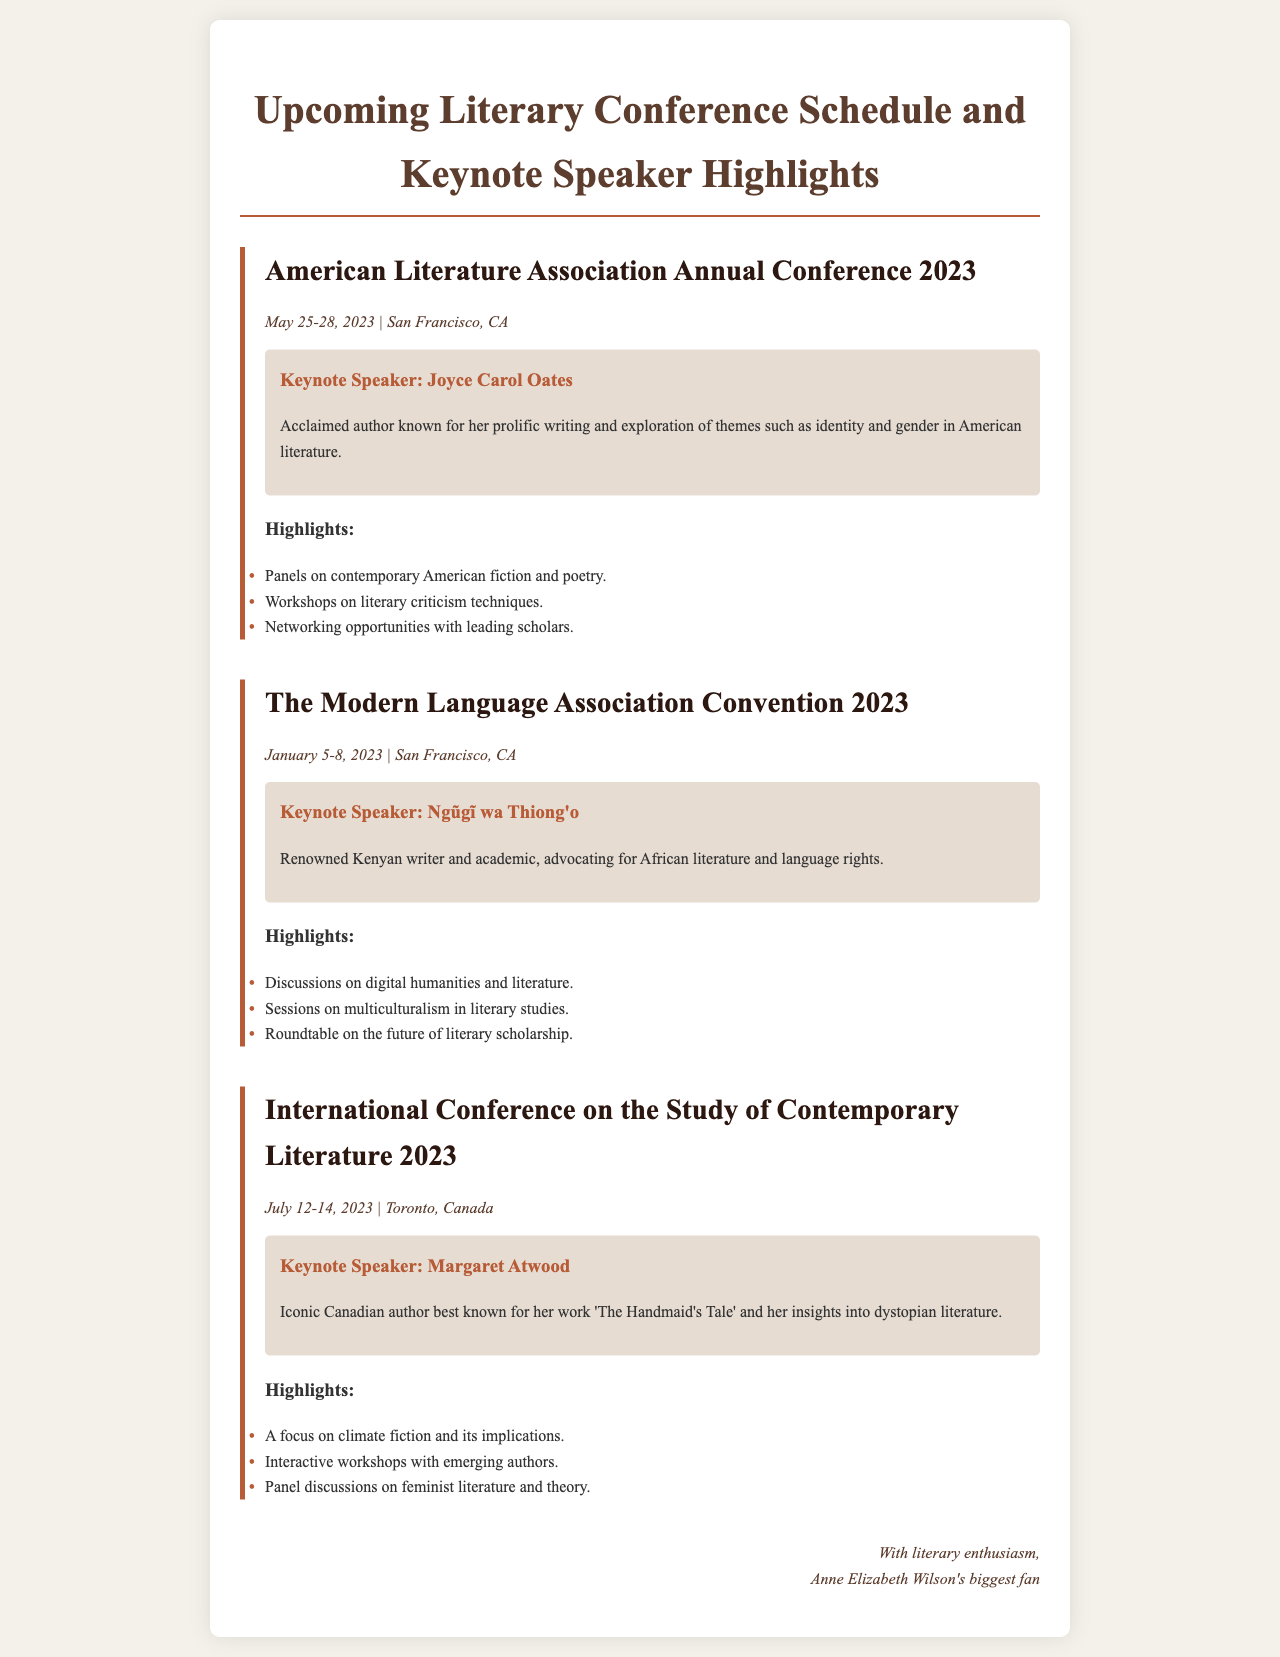What are the dates for the American Literature Association Annual Conference 2023? The dates are clearly stated in the conference section of the document.
Answer: May 25-28, 2023 Who is the keynote speaker for the International Conference on the Study of Contemporary Literature 2023? The document lists keynote speakers for each conference.
Answer: Margaret Atwood What is one of the highlights for The Modern Language Association Convention 2023? The highlights are listed under each conference and include various focus areas.
Answer: Discussions on digital humanities and literature Where will the American Literature Association Annual Conference 2023 be held? The location is mentioned in the conference details in the document.
Answer: San Francisco, CA What theme is emphasized in the keynote speech for the Modern Language Association Convention 2023? The theme reflects the background and advocacy of the keynote speaker mentioned in the section.
Answer: African literature and language rights How many conferences are mentioned in the email? The count can be obtained by evaluating the number of conference sections in the document.
Answer: Three What genre does Joyce Carol Oates primarily explore according to the email? The document describes her thematic focus in the keynote description.
Answer: Identity and gender What is the focus of the workshops at the International Conference on the Study of Contemporary Literature 2023? The focus is stated in the highlights section for the respective conference.
Answer: Climate fiction and its implications 